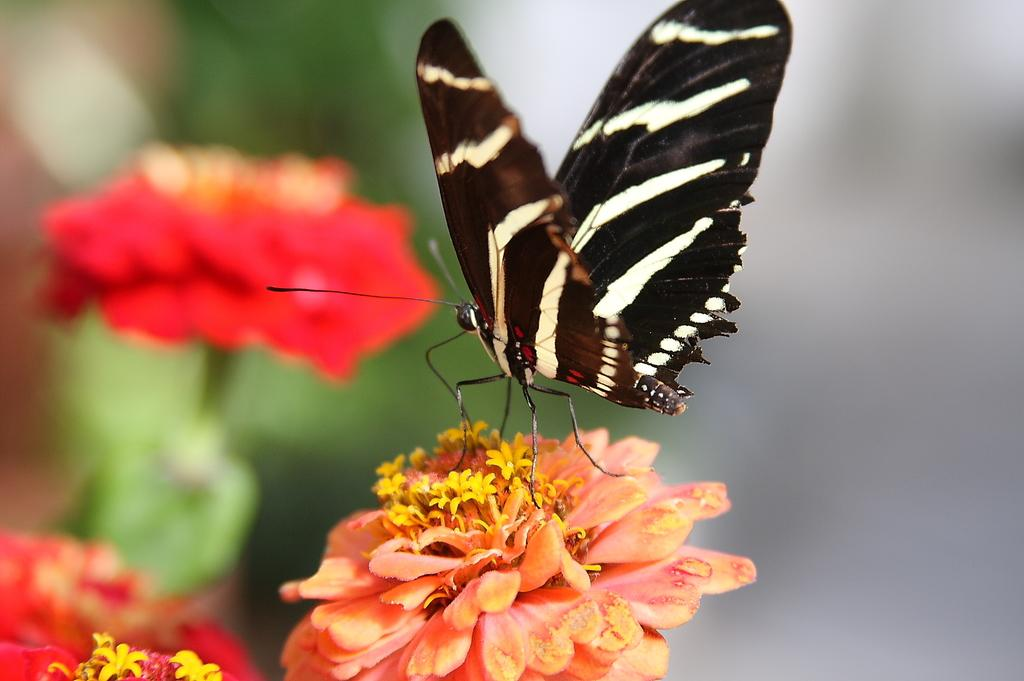What type of insect is in the image? There is a black butterfly in the image. Where is the butterfly located? The butterfly is on a flower. How many flowers are visible in the image? There are three flowers in the image, including the one with the butterfly. On which side of the image are the flowers located? The flowers are on the left side of the image. What type of meat is being served at the event in the image? There is no event or meat present in the image; it features a black butterfly on a flower. Can you describe the teeth of the butterfly in the image? Butterflies do not have teeth, so there is no information about teeth in the image. 